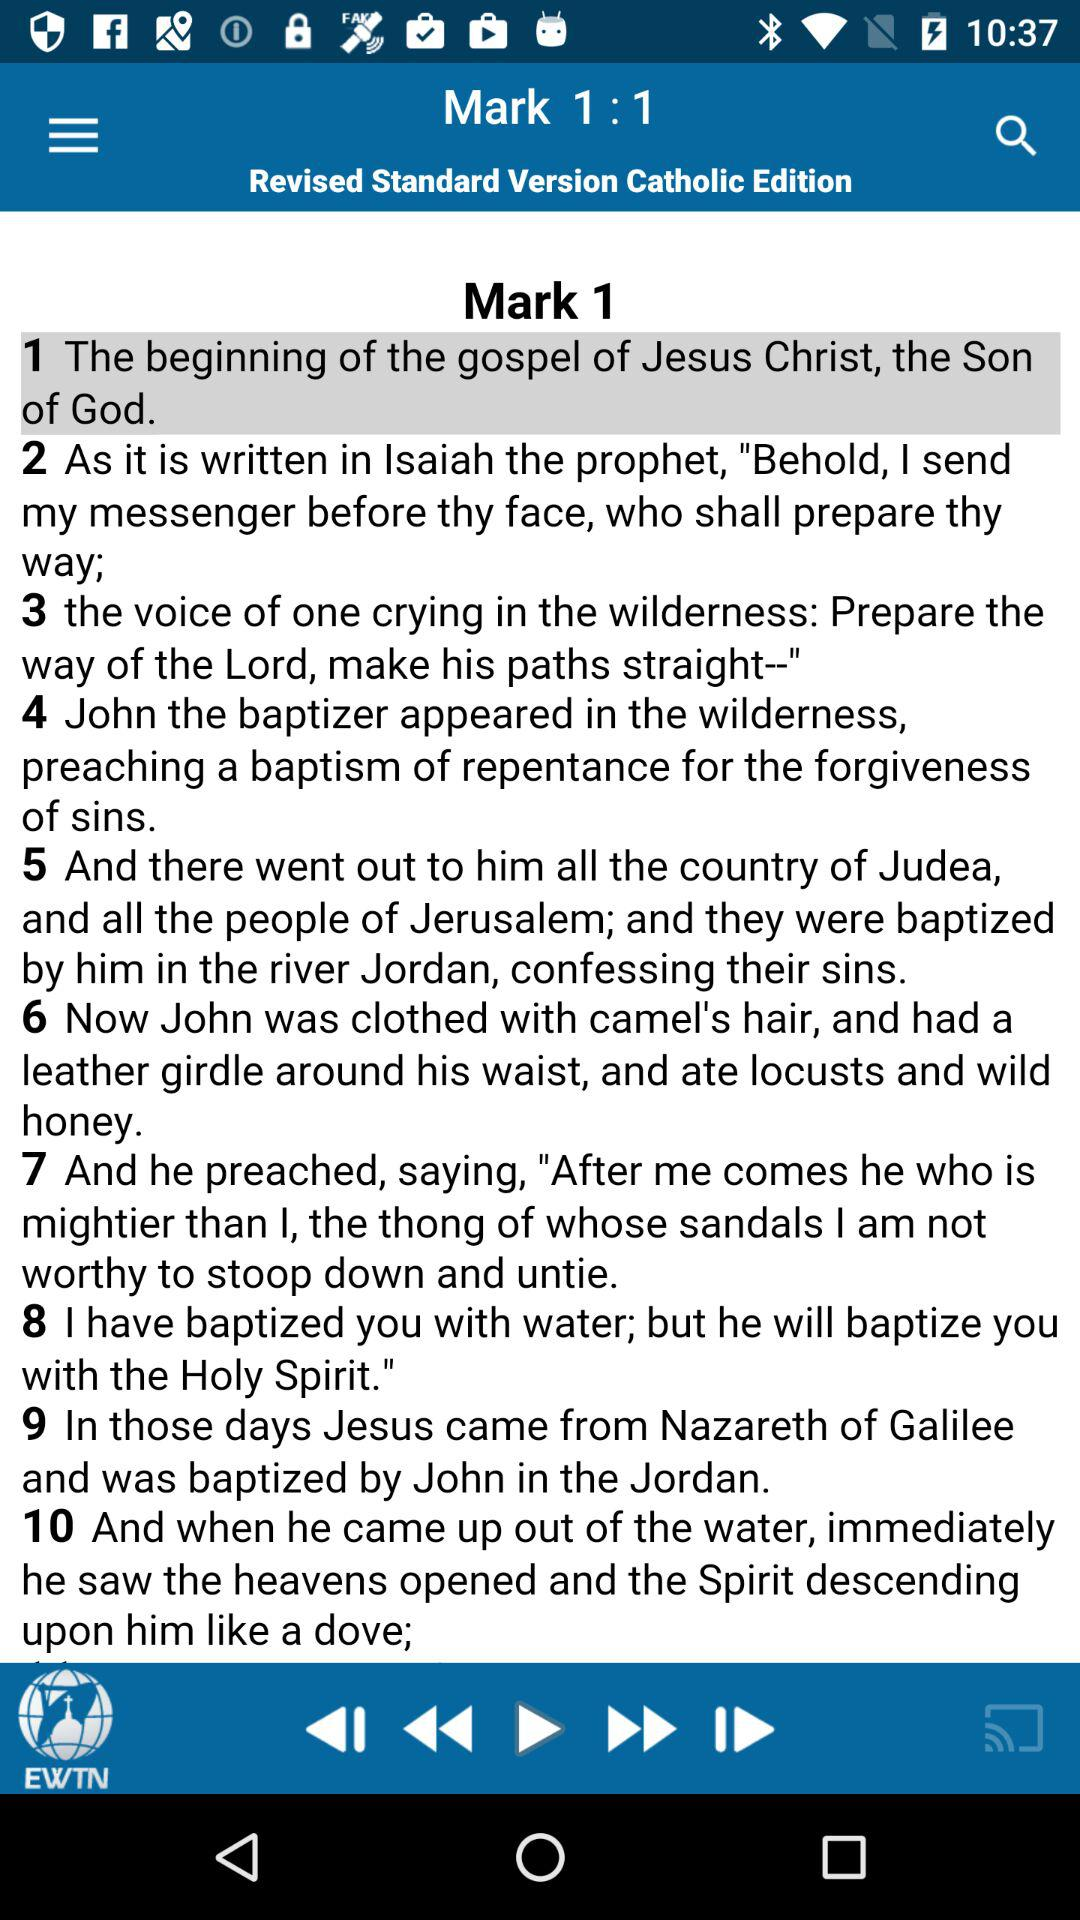What edition is displayed? The edition is "Revised Standard Version Catholic". 